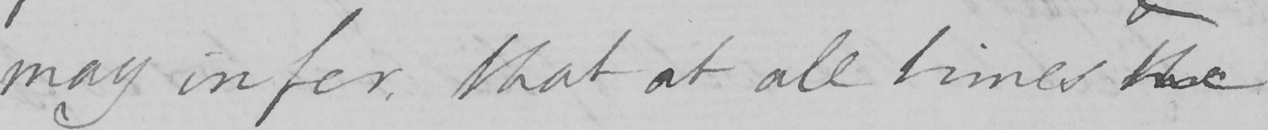What is written in this line of handwriting? may infer , that at all times the 